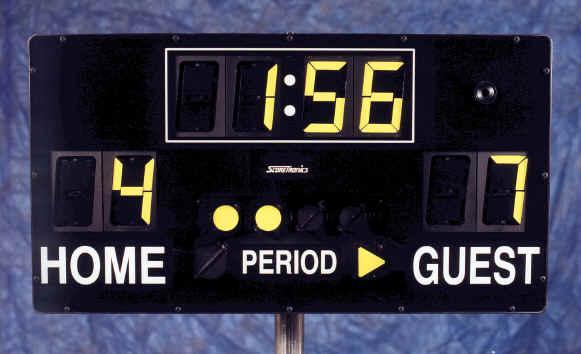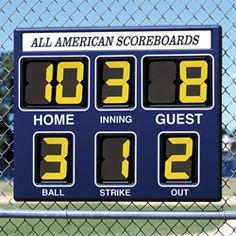The first image is the image on the left, the second image is the image on the right. Examine the images to the left and right. Is the description "The sum of each individual digit visible in both image is less than forty two." accurate? Answer yes or no. Yes. The first image is the image on the left, the second image is the image on the right. Assess this claim about the two images: "There are two scoreboards which list the home score on the left side and the guest score on the right side.". Correct or not? Answer yes or no. Yes. 